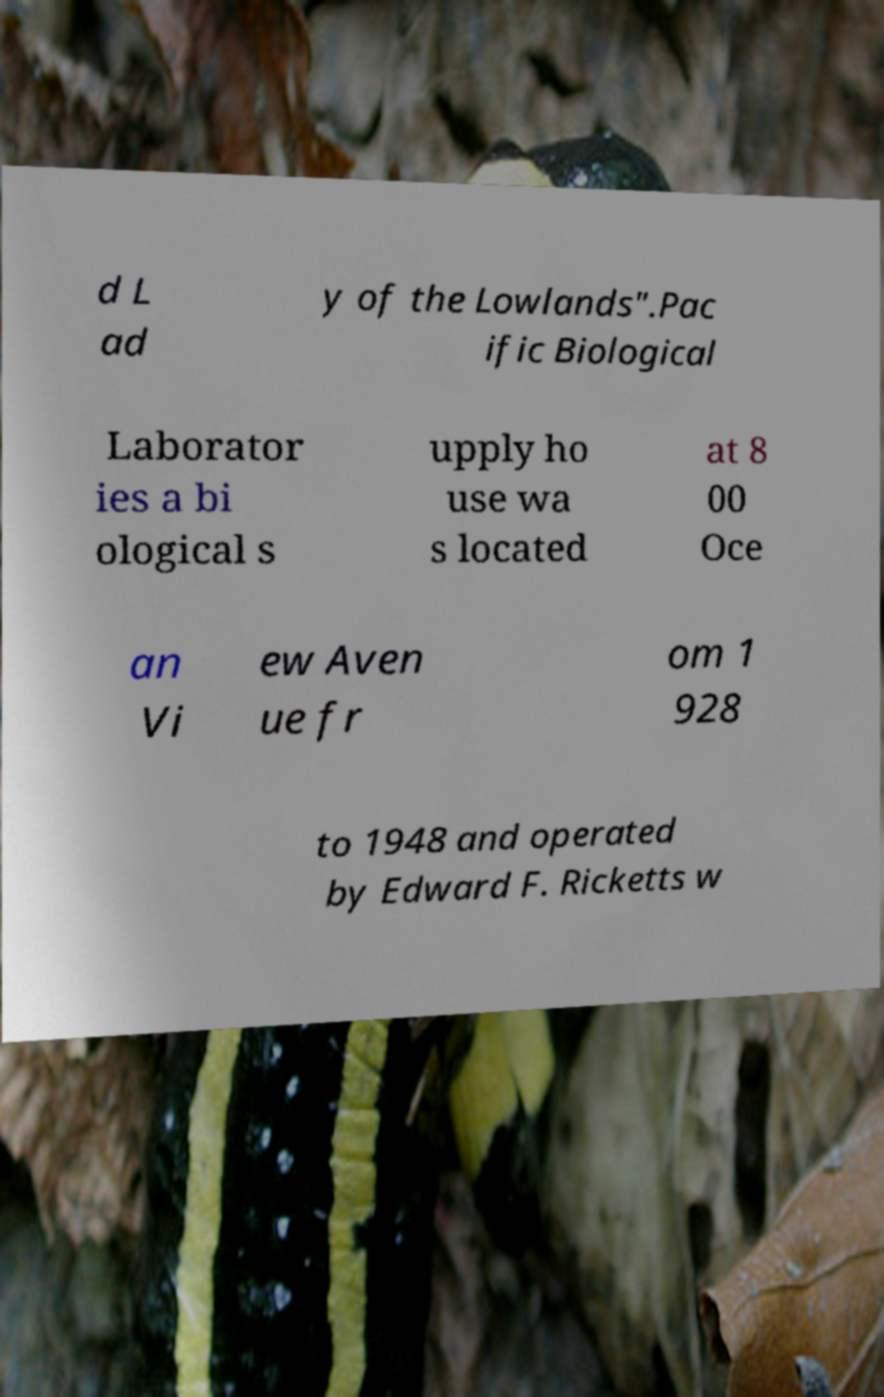For documentation purposes, I need the text within this image transcribed. Could you provide that? d L ad y of the Lowlands".Pac ific Biological Laborator ies a bi ological s upply ho use wa s located at 8 00 Oce an Vi ew Aven ue fr om 1 928 to 1948 and operated by Edward F. Ricketts w 